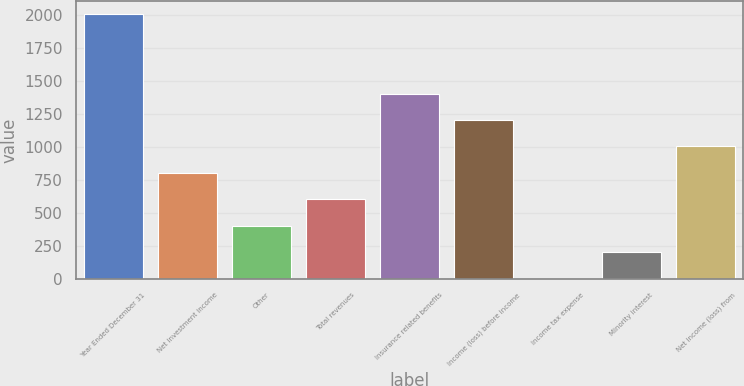Convert chart to OTSL. <chart><loc_0><loc_0><loc_500><loc_500><bar_chart><fcel>Year Ended December 31<fcel>Net investment income<fcel>Other<fcel>Total revenues<fcel>Insurance related benefits<fcel>Income (loss) before income<fcel>Income tax expense<fcel>Minority interest<fcel>Net income (loss) from<nl><fcel>2004<fcel>802.32<fcel>401.76<fcel>602.04<fcel>1403.16<fcel>1202.88<fcel>1.2<fcel>201.48<fcel>1002.6<nl></chart> 